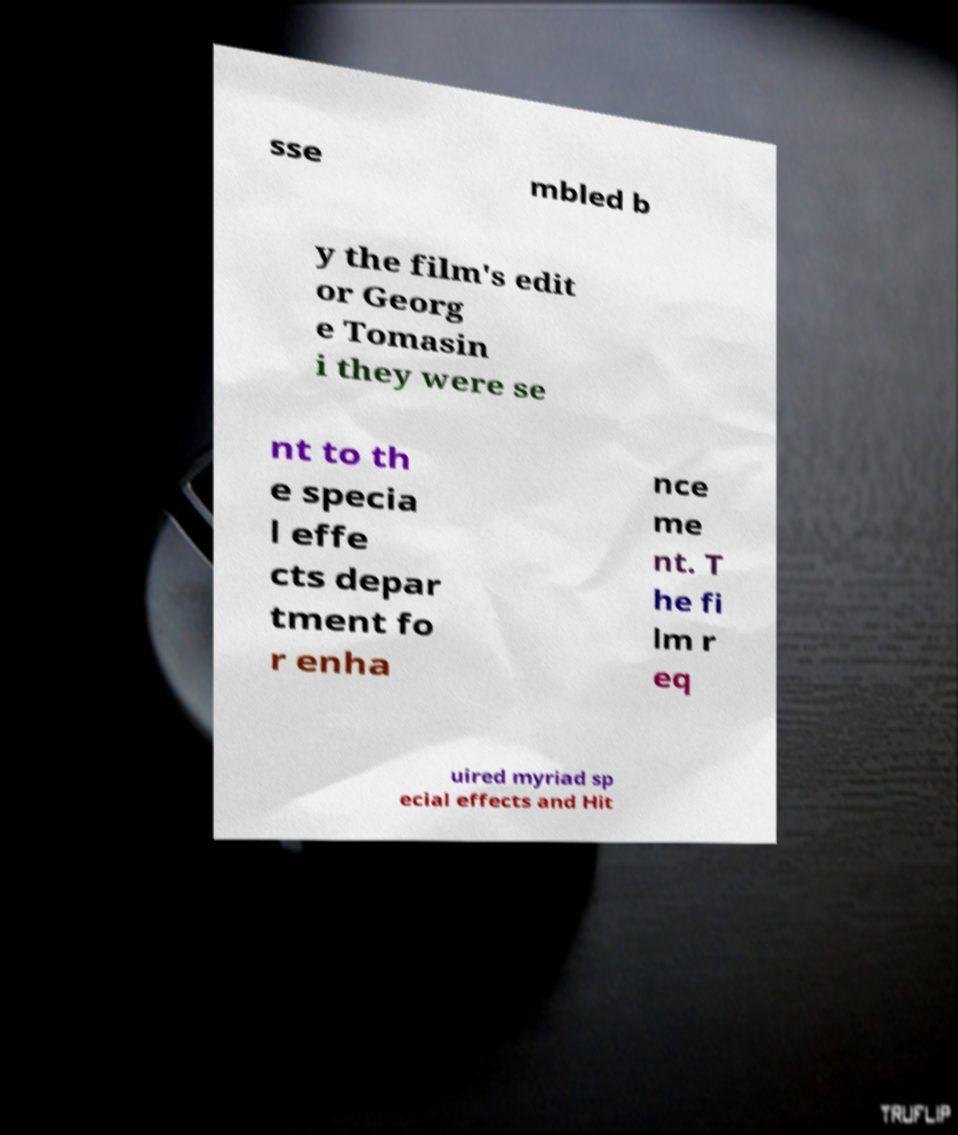Please read and relay the text visible in this image. What does it say? sse mbled b y the film's edit or Georg e Tomasin i they were se nt to th e specia l effe cts depar tment fo r enha nce me nt. T he fi lm r eq uired myriad sp ecial effects and Hit 